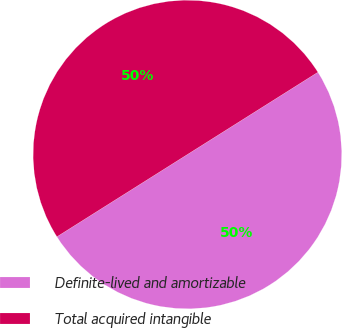Convert chart. <chart><loc_0><loc_0><loc_500><loc_500><pie_chart><fcel>Definite-lived and amortizable<fcel>Total acquired intangible<nl><fcel>50.0%<fcel>50.0%<nl></chart> 